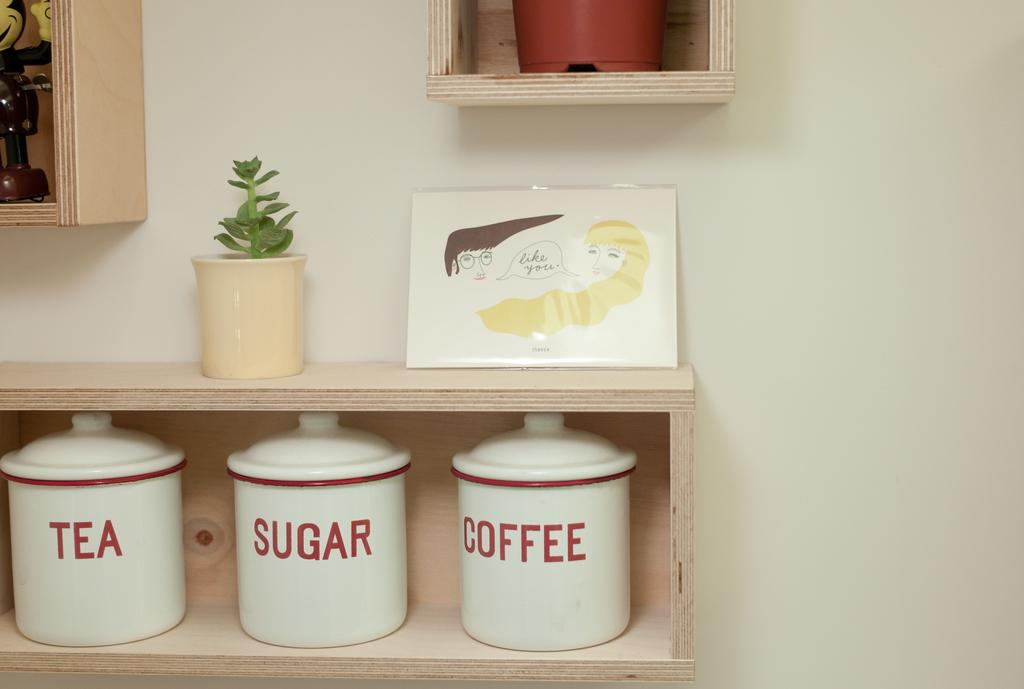<image>
Create a compact narrative representing the image presented. Three white containers including one that says TEA next to one another. 